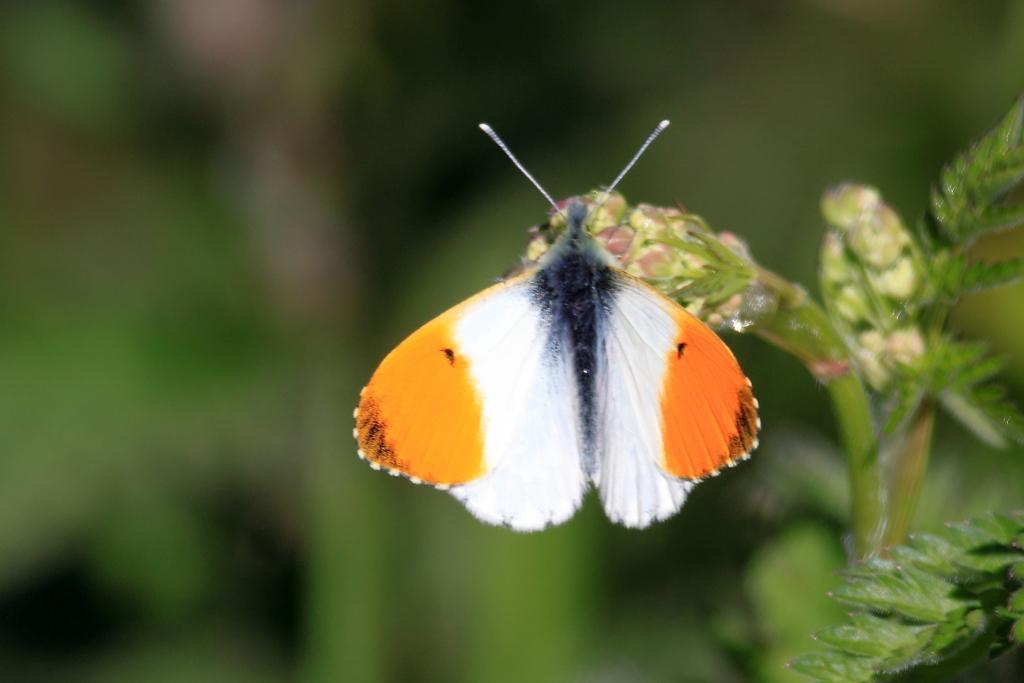Can you describe this image briefly? the background of the picture is very blurry. Here we can see a plant and this is a butterfly in white and orange in colour. 